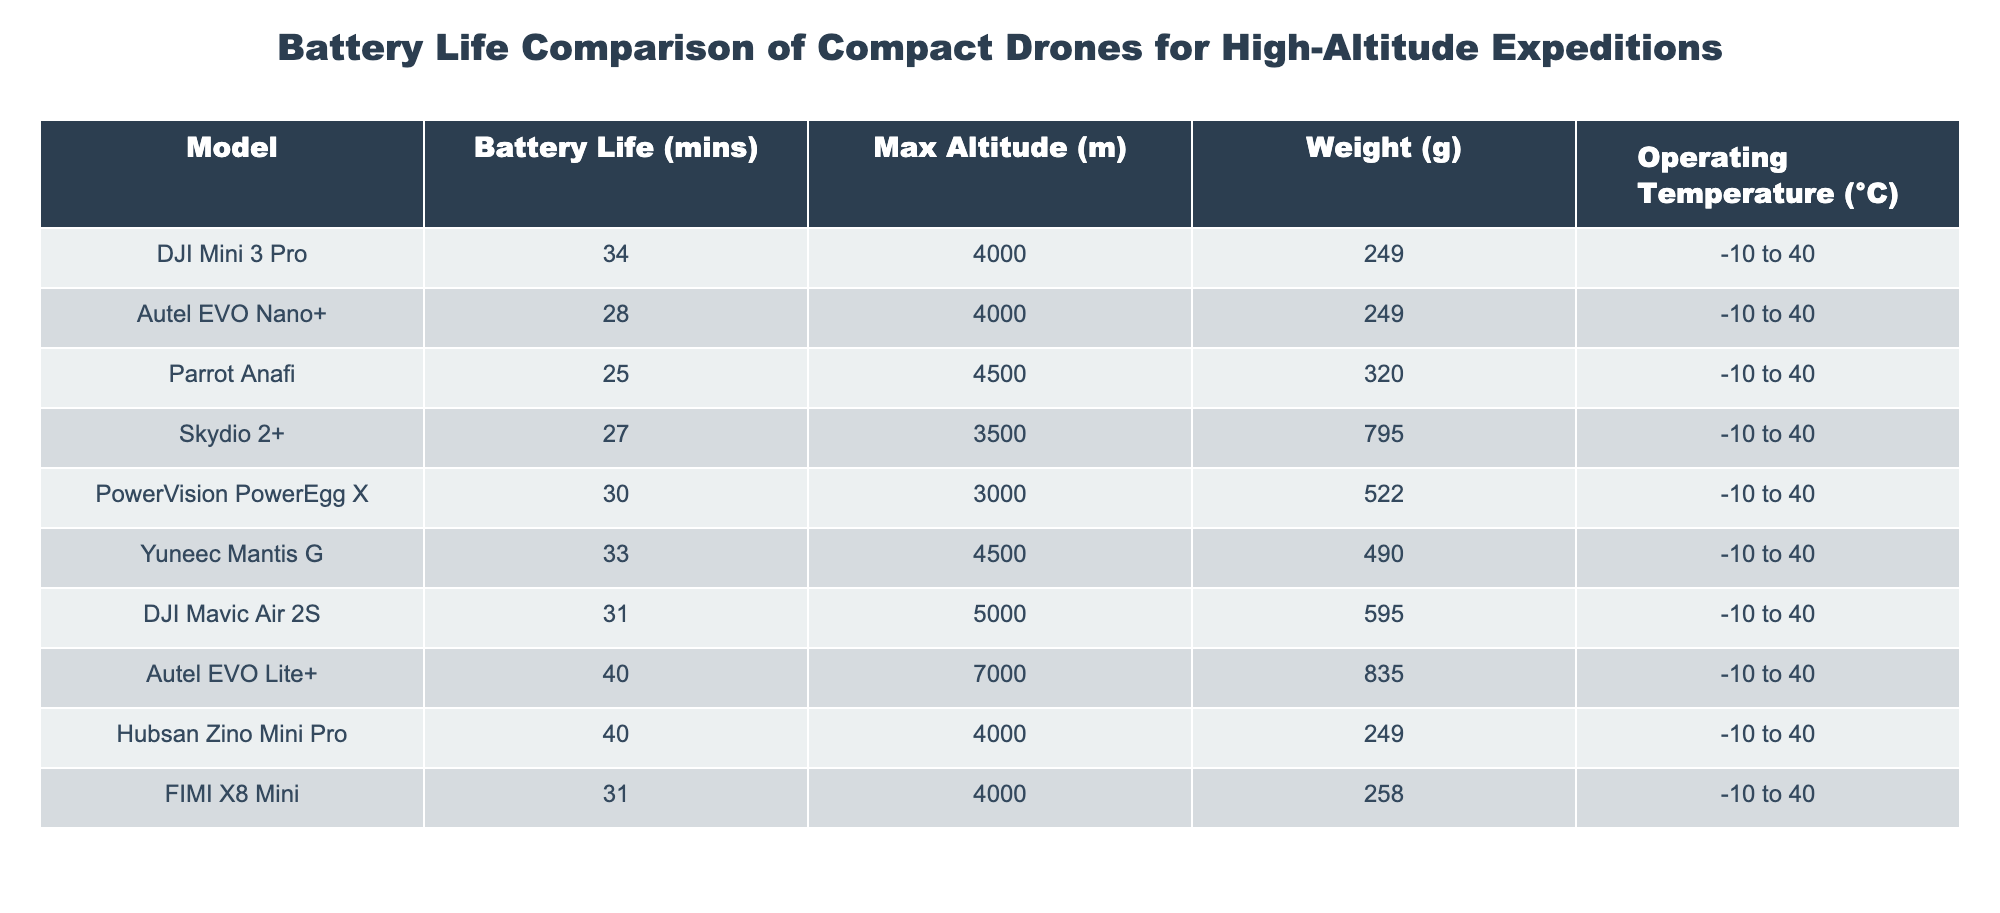What is the battery life of the DJI Mini 3 Pro? The battery life is listed in the table directly beside the model name for the DJI Mini 3 Pro, which shows 34 minutes.
Answer: 34 minutes Which drone has the longest battery life? To find the longest battery life, we compare the battery life values for all drones in the table. The Autel EVO Lite+ and Hubsan Zino Mini Pro both have a battery life of 40 minutes, which is the highest among all listed models.
Answer: Autel EVO Lite+ and Hubsan Zino Mini Pro How many drones can operate above 4000 meters? We need to filter the data based on the maximum altitude and count the number of models that have a maximum altitude greater than 4000 meters. The table shows the Parrot Anafi, DJI Mavic Air 2S, Autel EVO Lite+, and the Yuneec Mantis G, which results in a total of 4 models.
Answer: 4 drones What is the average battery life of the drones listed? To find the average, we first sum the battery lives: 34 + 28 + 25 + 27 + 30 + 33 + 31 + 40 + 40 + 31 =  359 minutes. Then, we divide by the number of drones, which is 10, resulting in an average of 35.9 minutes.
Answer: 35.9 minutes Is the Skydio 2+ suitable for temperature ranges below -10°C? The operating temperature for the Skydio 2+ is stated as -10 to 40°C in the table, which means it is not suitable for temperatures below -10°C, confirming a "No" answer.
Answer: No Which drone has a weight greater than 500g but less than 600g? By reviewing the weight column, we check each drone's weight against the criteria given. The drone that meets these conditions is the DJI Mavic Air 2S, which has a weight of 595g.
Answer: DJI Mavic Air 2S How does the battery life of the Autel EVO Nano+ compare to the Yuneec Mantis G? The battery life of the Autel EVO Nano+ is 28 minutes, while the Yuneec Mantis G has a battery life of 33 minutes. To compare, the Yuneec Mantis G has a longer battery life of 5 minutes compared to the Autel EVO Nano+.
Answer: 5 minutes longer Which two drones have the closest battery life, and what is their difference? On examining the battery life values, the closest are Skydio 2+ with 27 minutes and Parrot Anafi with 25 minutes. Their difference is 2 minutes, with the Skydio 2+ having the longer battery life.
Answer: 2 minutes Does any drone listed have a battery life of 34 minutes? By reviewing the battery life data in the table, we see that the DJI Mini 3 Pro has a battery life of 34 minutes, confirming that the answer is "Yes".
Answer: Yes 